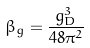<formula> <loc_0><loc_0><loc_500><loc_500>\beta _ { g } = \frac { g _ { D } ^ { 3 } } { 4 8 \pi ^ { 2 } }</formula> 